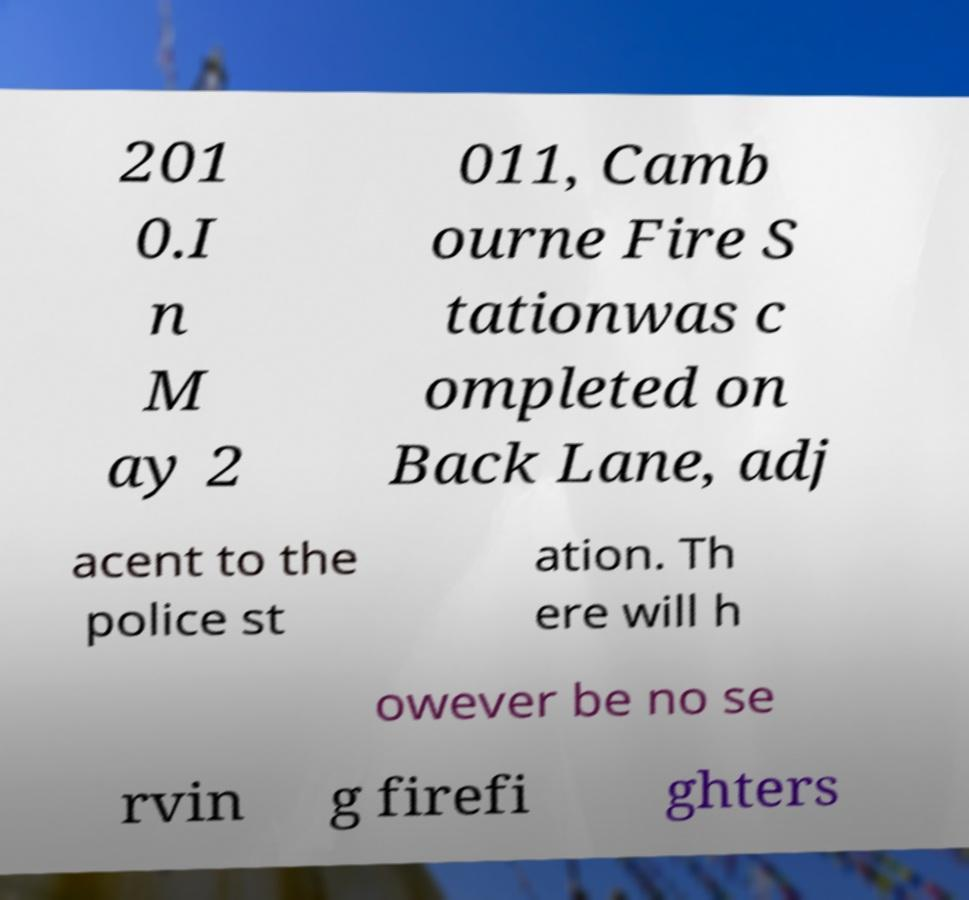I need the written content from this picture converted into text. Can you do that? 201 0.I n M ay 2 011, Camb ourne Fire S tationwas c ompleted on Back Lane, adj acent to the police st ation. Th ere will h owever be no se rvin g firefi ghters 